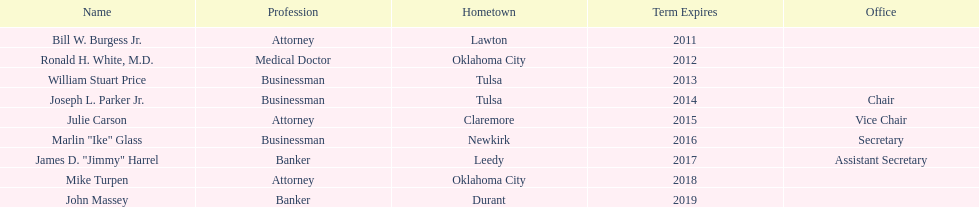Besides joseph l. parker jr., who are the other members of the state regents from tulsa? William Stuart Price. 